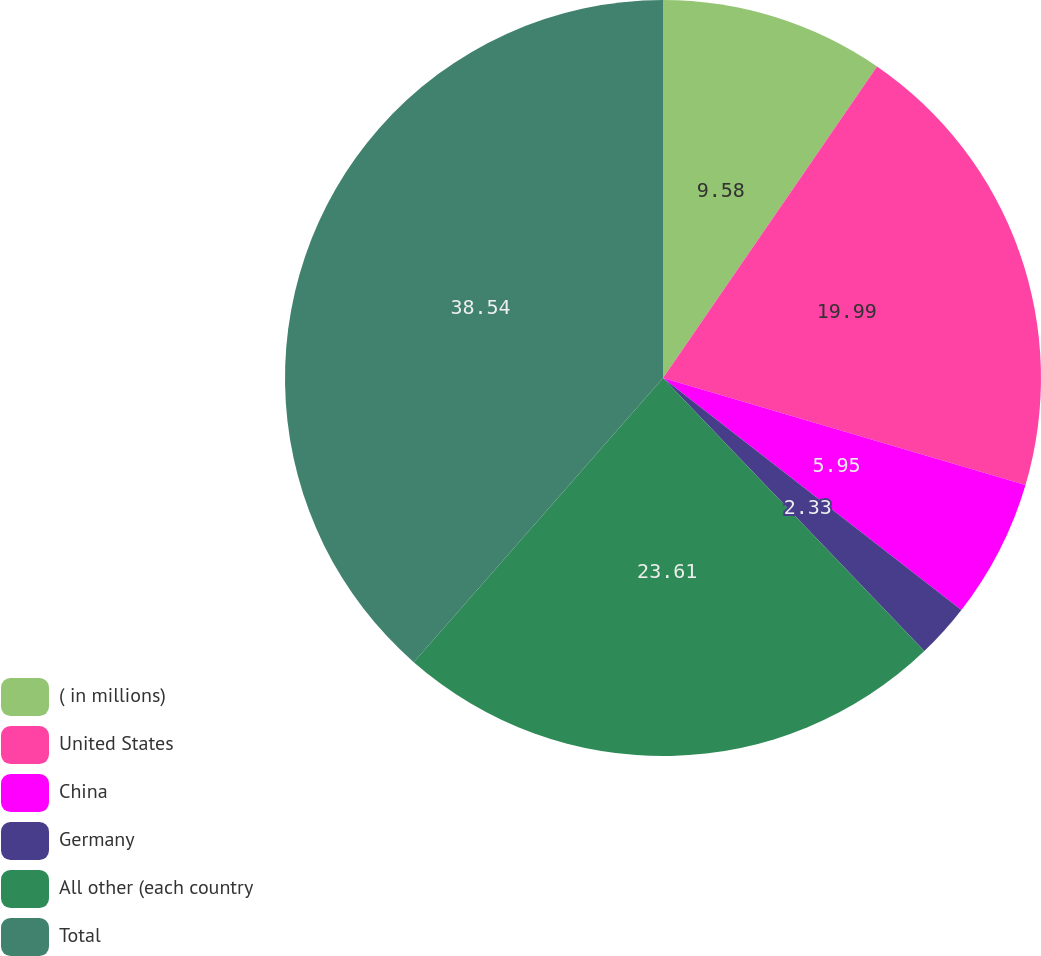Convert chart. <chart><loc_0><loc_0><loc_500><loc_500><pie_chart><fcel>( in millions)<fcel>United States<fcel>China<fcel>Germany<fcel>All other (each country<fcel>Total<nl><fcel>9.58%<fcel>19.99%<fcel>5.95%<fcel>2.33%<fcel>23.61%<fcel>38.54%<nl></chart> 